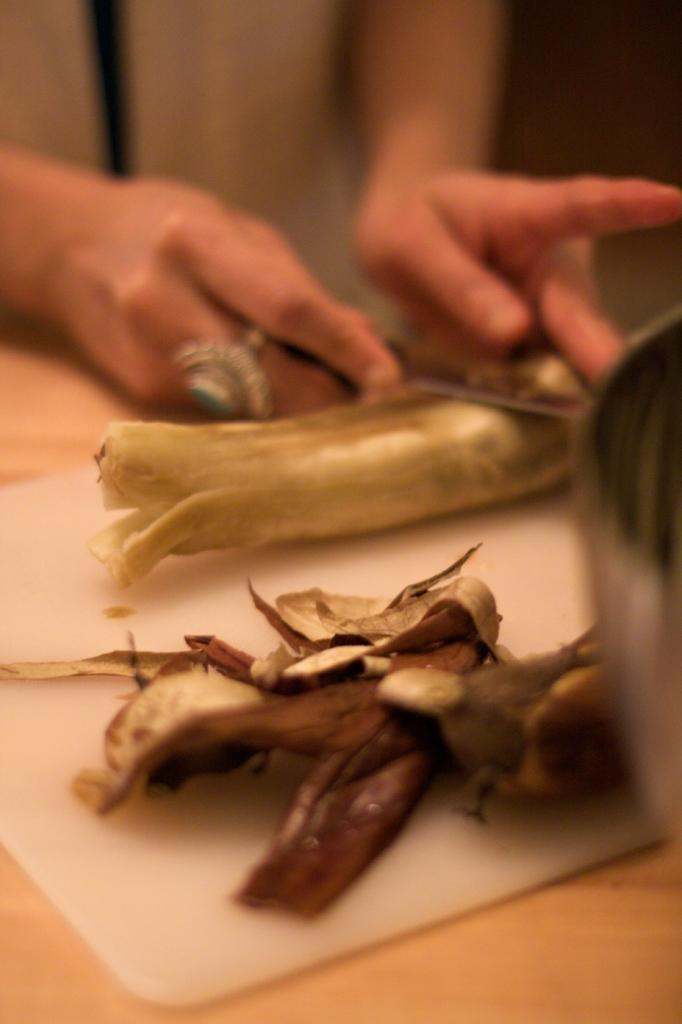What is the main object in the center of the image? There is a table in the center of the image. What is placed on the table? A cutting board is present on the table, along with peels and a fruit. What is the person in the background doing? The person is cutting a fruit. Can you describe the fruit that is being cut? Unfortunately, the specific type of fruit cannot be determined from the provided facts. What type of veil can be seen on the fruit in the image? There is no veil present on the fruit in the image. What type of disease is being treated by the person in the image? There is no indication of a disease or medical treatment in the image. 